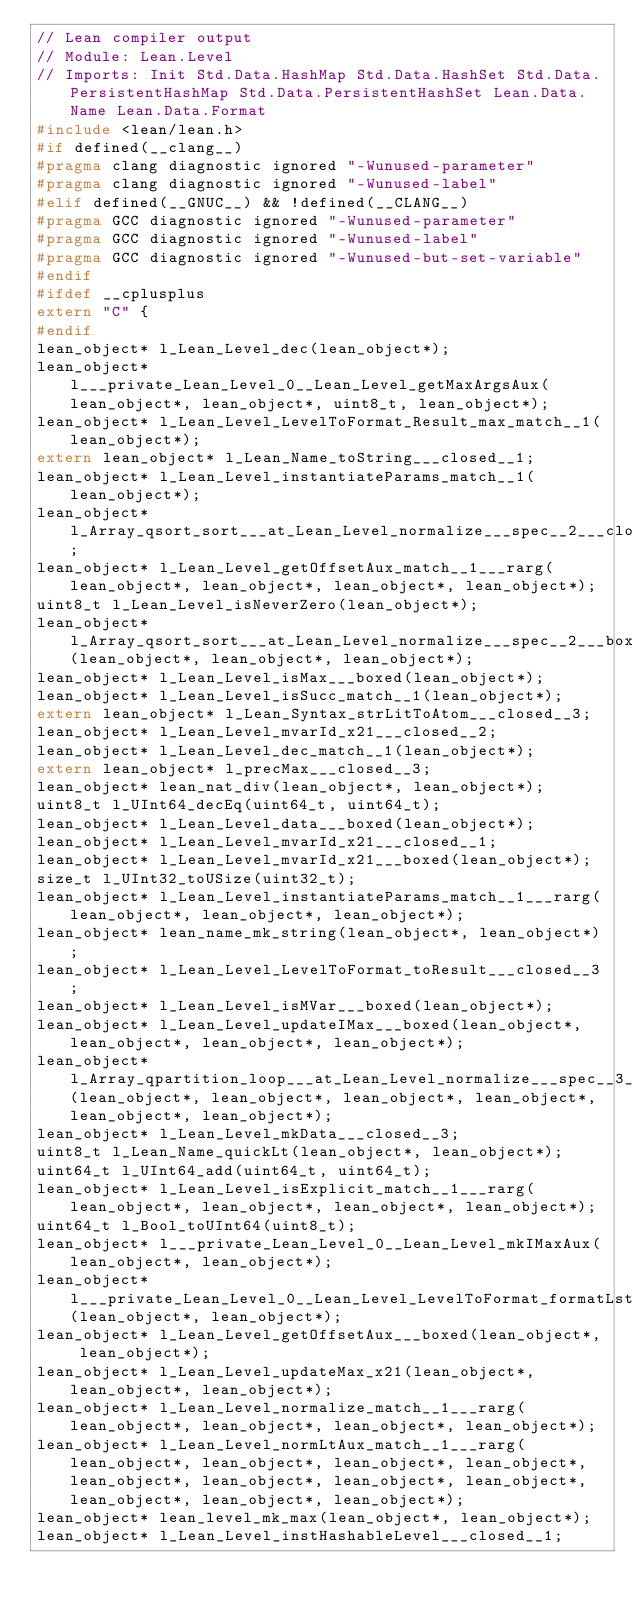Convert code to text. <code><loc_0><loc_0><loc_500><loc_500><_C_>// Lean compiler output
// Module: Lean.Level
// Imports: Init Std.Data.HashMap Std.Data.HashSet Std.Data.PersistentHashMap Std.Data.PersistentHashSet Lean.Data.Name Lean.Data.Format
#include <lean/lean.h>
#if defined(__clang__)
#pragma clang diagnostic ignored "-Wunused-parameter"
#pragma clang diagnostic ignored "-Wunused-label"
#elif defined(__GNUC__) && !defined(__CLANG__)
#pragma GCC diagnostic ignored "-Wunused-parameter"
#pragma GCC diagnostic ignored "-Wunused-label"
#pragma GCC diagnostic ignored "-Wunused-but-set-variable"
#endif
#ifdef __cplusplus
extern "C" {
#endif
lean_object* l_Lean_Level_dec(lean_object*);
lean_object* l___private_Lean_Level_0__Lean_Level_getMaxArgsAux(lean_object*, lean_object*, uint8_t, lean_object*);
lean_object* l_Lean_Level_LevelToFormat_Result_max_match__1(lean_object*);
extern lean_object* l_Lean_Name_toString___closed__1;
lean_object* l_Lean_Level_instantiateParams_match__1(lean_object*);
lean_object* l_Array_qsort_sort___at_Lean_Level_normalize___spec__2___closed__1;
lean_object* l_Lean_Level_getOffsetAux_match__1___rarg(lean_object*, lean_object*, lean_object*, lean_object*);
uint8_t l_Lean_Level_isNeverZero(lean_object*);
lean_object* l_Array_qsort_sort___at_Lean_Level_normalize___spec__2___boxed(lean_object*, lean_object*, lean_object*);
lean_object* l_Lean_Level_isMax___boxed(lean_object*);
lean_object* l_Lean_Level_isSucc_match__1(lean_object*);
extern lean_object* l_Lean_Syntax_strLitToAtom___closed__3;
lean_object* l_Lean_Level_mvarId_x21___closed__2;
lean_object* l_Lean_Level_dec_match__1(lean_object*);
extern lean_object* l_precMax___closed__3;
lean_object* lean_nat_div(lean_object*, lean_object*);
uint8_t l_UInt64_decEq(uint64_t, uint64_t);
lean_object* l_Lean_Level_data___boxed(lean_object*);
lean_object* l_Lean_Level_mvarId_x21___closed__1;
lean_object* l_Lean_Level_mvarId_x21___boxed(lean_object*);
size_t l_UInt32_toUSize(uint32_t);
lean_object* l_Lean_Level_instantiateParams_match__1___rarg(lean_object*, lean_object*, lean_object*);
lean_object* lean_name_mk_string(lean_object*, lean_object*);
lean_object* l_Lean_Level_LevelToFormat_toResult___closed__3;
lean_object* l_Lean_Level_isMVar___boxed(lean_object*);
lean_object* l_Lean_Level_updateIMax___boxed(lean_object*, lean_object*, lean_object*, lean_object*);
lean_object* l_Array_qpartition_loop___at_Lean_Level_normalize___spec__3___boxed(lean_object*, lean_object*, lean_object*, lean_object*, lean_object*, lean_object*);
lean_object* l_Lean_Level_mkData___closed__3;
uint8_t l_Lean_Name_quickLt(lean_object*, lean_object*);
uint64_t l_UInt64_add(uint64_t, uint64_t);
lean_object* l_Lean_Level_isExplicit_match__1___rarg(lean_object*, lean_object*, lean_object*, lean_object*);
uint64_t l_Bool_toUInt64(uint8_t);
lean_object* l___private_Lean_Level_0__Lean_Level_mkIMaxAux(lean_object*, lean_object*);
lean_object* l___private_Lean_Level_0__Lean_Level_LevelToFormat_formatLst(lean_object*, lean_object*);
lean_object* l_Lean_Level_getOffsetAux___boxed(lean_object*, lean_object*);
lean_object* l_Lean_Level_updateMax_x21(lean_object*, lean_object*, lean_object*);
lean_object* l_Lean_Level_normalize_match__1___rarg(lean_object*, lean_object*, lean_object*, lean_object*);
lean_object* l_Lean_Level_normLtAux_match__1___rarg(lean_object*, lean_object*, lean_object*, lean_object*, lean_object*, lean_object*, lean_object*, lean_object*, lean_object*, lean_object*, lean_object*);
lean_object* lean_level_mk_max(lean_object*, lean_object*);
lean_object* l_Lean_Level_instHashableLevel___closed__1;</code> 